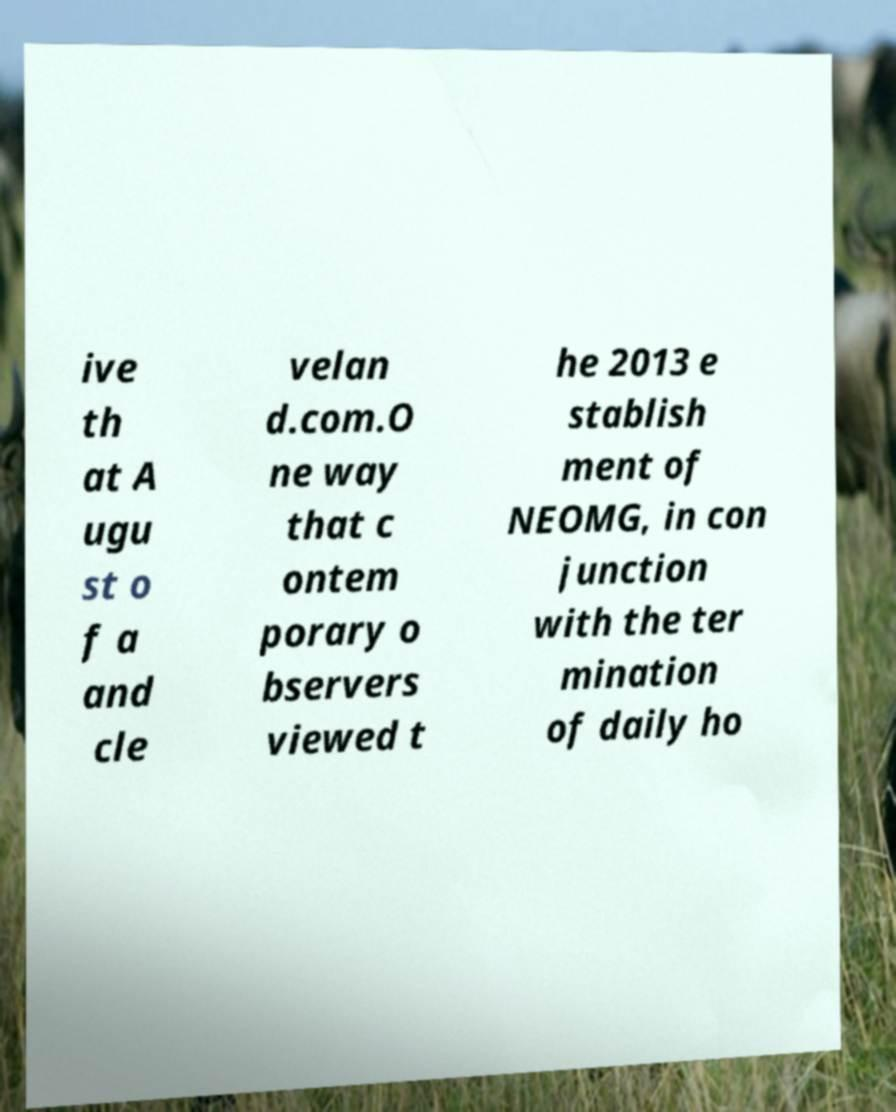Could you assist in decoding the text presented in this image and type it out clearly? ive th at A ugu st o f a and cle velan d.com.O ne way that c ontem porary o bservers viewed t he 2013 e stablish ment of NEOMG, in con junction with the ter mination of daily ho 